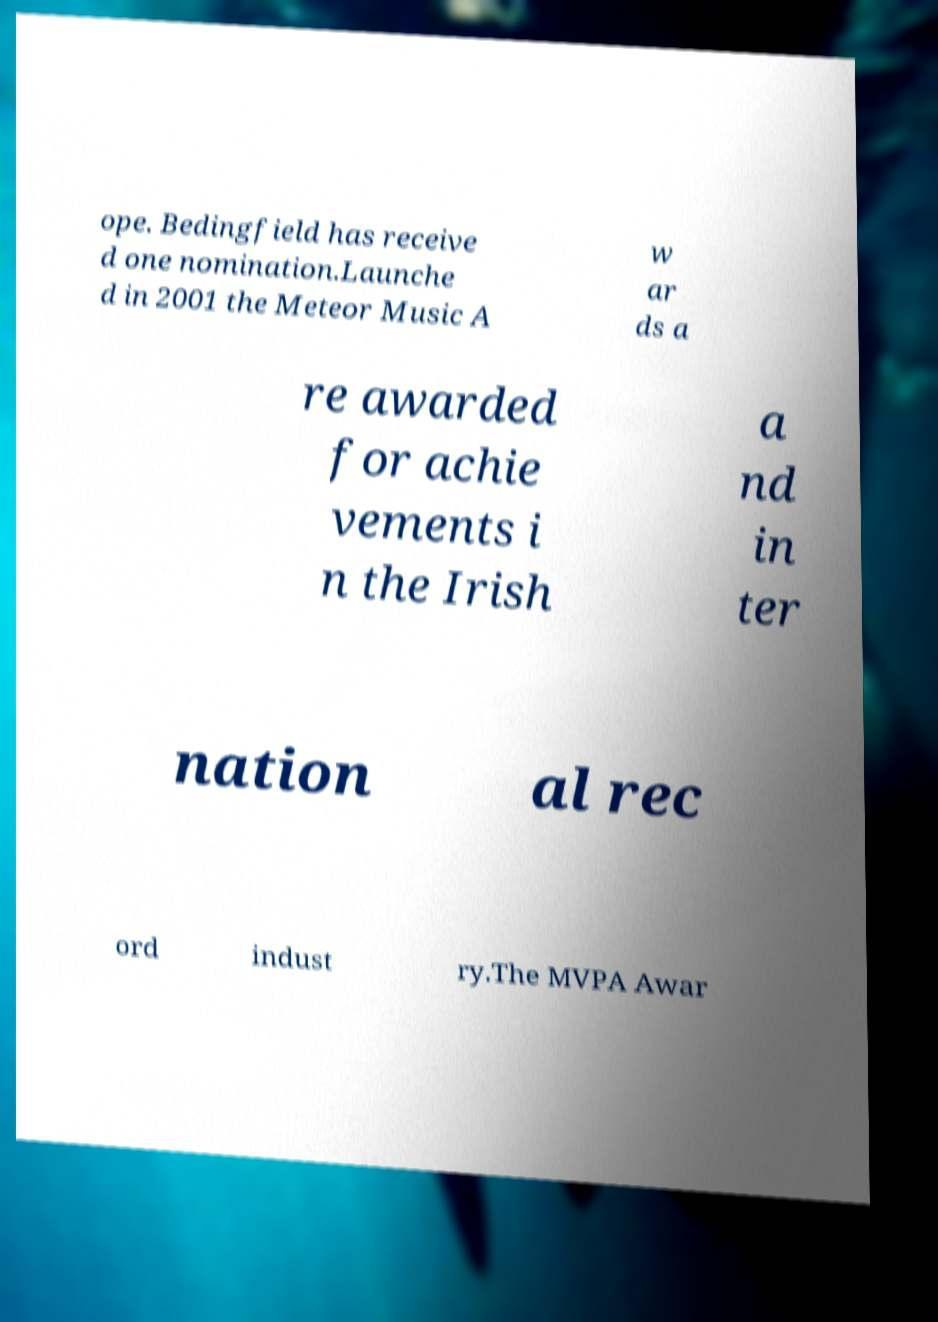Could you assist in decoding the text presented in this image and type it out clearly? ope. Bedingfield has receive d one nomination.Launche d in 2001 the Meteor Music A w ar ds a re awarded for achie vements i n the Irish a nd in ter nation al rec ord indust ry.The MVPA Awar 